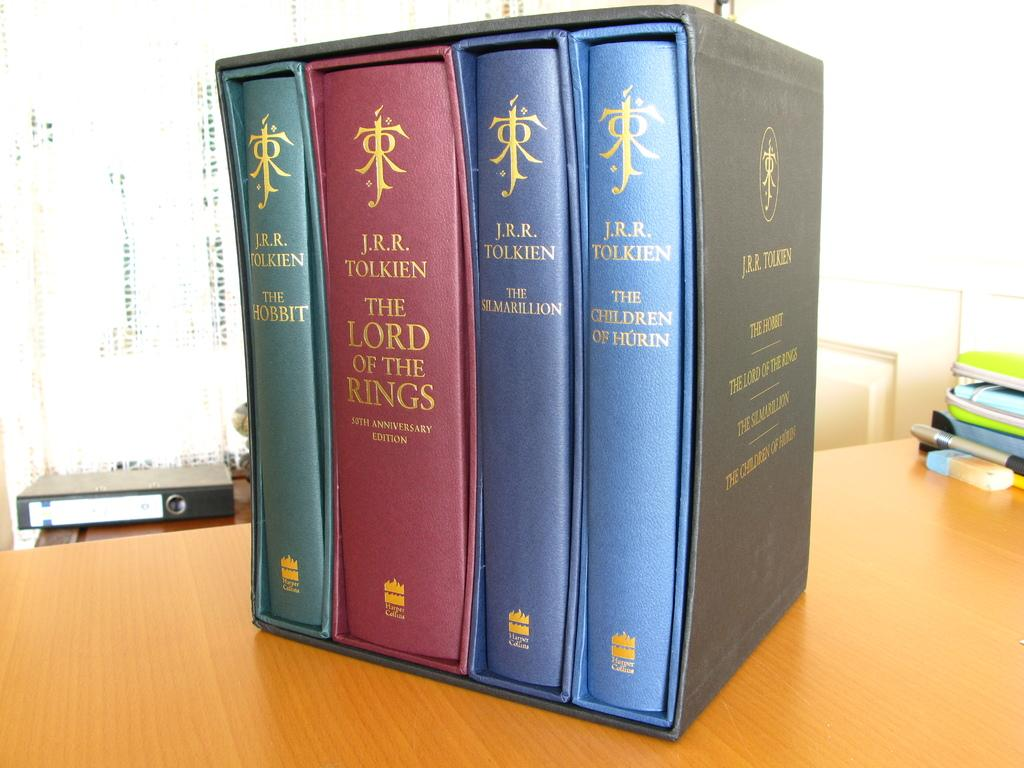<image>
Present a compact description of the photo's key features. A set of J.R.R. Tolkein's books are in a fancy box sitting on a desk. 